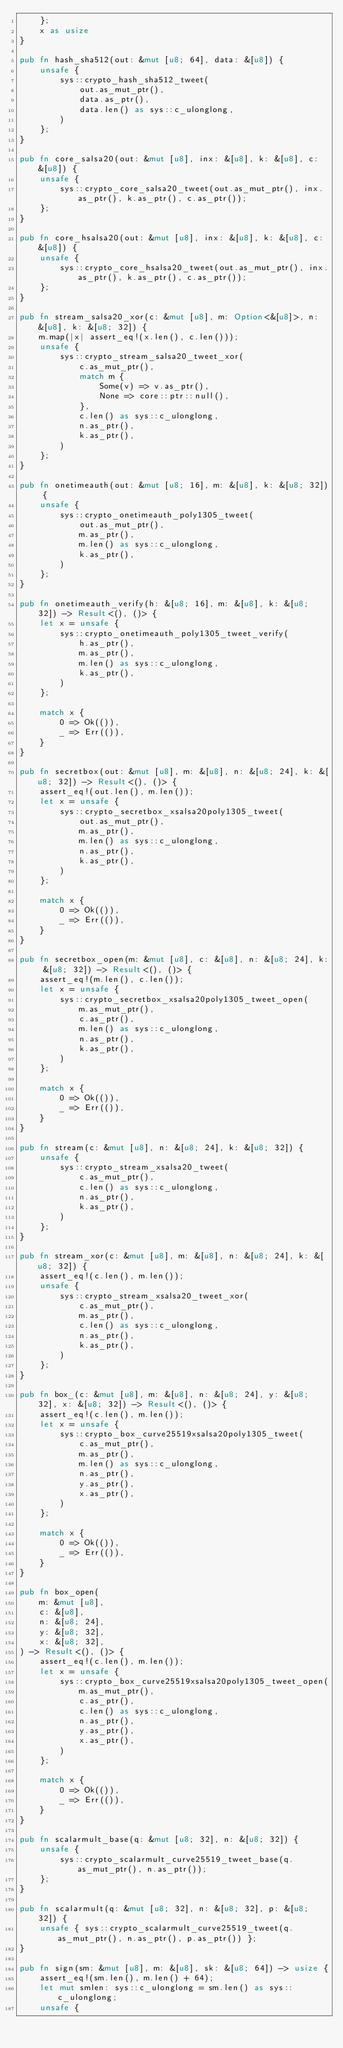Convert code to text. <code><loc_0><loc_0><loc_500><loc_500><_Rust_>    };
    x as usize
}

pub fn hash_sha512(out: &mut [u8; 64], data: &[u8]) {
    unsafe {
        sys::crypto_hash_sha512_tweet(
            out.as_mut_ptr(),
            data.as_ptr(),
            data.len() as sys::c_ulonglong,
        )
    };
}

pub fn core_salsa20(out: &mut [u8], inx: &[u8], k: &[u8], c: &[u8]) {
    unsafe {
        sys::crypto_core_salsa20_tweet(out.as_mut_ptr(), inx.as_ptr(), k.as_ptr(), c.as_ptr());
    };
}

pub fn core_hsalsa20(out: &mut [u8], inx: &[u8], k: &[u8], c: &[u8]) {
    unsafe {
        sys::crypto_core_hsalsa20_tweet(out.as_mut_ptr(), inx.as_ptr(), k.as_ptr(), c.as_ptr());
    };
}

pub fn stream_salsa20_xor(c: &mut [u8], m: Option<&[u8]>, n: &[u8], k: &[u8; 32]) {
    m.map(|x| assert_eq!(x.len(), c.len()));
    unsafe {
        sys::crypto_stream_salsa20_tweet_xor(
            c.as_mut_ptr(),
            match m {
                Some(v) => v.as_ptr(),
                None => core::ptr::null(),
            },
            c.len() as sys::c_ulonglong,
            n.as_ptr(),
            k.as_ptr(),
        )
    };
}

pub fn onetimeauth(out: &mut [u8; 16], m: &[u8], k: &[u8; 32]) {
    unsafe {
        sys::crypto_onetimeauth_poly1305_tweet(
            out.as_mut_ptr(),
            m.as_ptr(),
            m.len() as sys::c_ulonglong,
            k.as_ptr(),
        )
    };
}

pub fn onetimeauth_verify(h: &[u8; 16], m: &[u8], k: &[u8; 32]) -> Result<(), ()> {
    let x = unsafe {
        sys::crypto_onetimeauth_poly1305_tweet_verify(
            h.as_ptr(),
            m.as_ptr(),
            m.len() as sys::c_ulonglong,
            k.as_ptr(),
        )
    };

    match x {
        0 => Ok(()),
        _ => Err(()),
    }
}

pub fn secretbox(out: &mut [u8], m: &[u8], n: &[u8; 24], k: &[u8; 32]) -> Result<(), ()> {
    assert_eq!(out.len(), m.len());
    let x = unsafe {
        sys::crypto_secretbox_xsalsa20poly1305_tweet(
            out.as_mut_ptr(),
            m.as_ptr(),
            m.len() as sys::c_ulonglong,
            n.as_ptr(),
            k.as_ptr(),
        )
    };

    match x {
        0 => Ok(()),
        _ => Err(()),
    }
}

pub fn secretbox_open(m: &mut [u8], c: &[u8], n: &[u8; 24], k: &[u8; 32]) -> Result<(), ()> {
    assert_eq!(m.len(), c.len());
    let x = unsafe {
        sys::crypto_secretbox_xsalsa20poly1305_tweet_open(
            m.as_mut_ptr(),
            c.as_ptr(),
            m.len() as sys::c_ulonglong,
            n.as_ptr(),
            k.as_ptr(),
        )
    };

    match x {
        0 => Ok(()),
        _ => Err(()),
    }
}

pub fn stream(c: &mut [u8], n: &[u8; 24], k: &[u8; 32]) {
    unsafe {
        sys::crypto_stream_xsalsa20_tweet(
            c.as_mut_ptr(),
            c.len() as sys::c_ulonglong,
            n.as_ptr(),
            k.as_ptr(),
        )
    };
}

pub fn stream_xor(c: &mut [u8], m: &[u8], n: &[u8; 24], k: &[u8; 32]) {
    assert_eq!(c.len(), m.len());
    unsafe {
        sys::crypto_stream_xsalsa20_tweet_xor(
            c.as_mut_ptr(),
            m.as_ptr(),
            c.len() as sys::c_ulonglong,
            n.as_ptr(),
            k.as_ptr(),
        )
    };
}

pub fn box_(c: &mut [u8], m: &[u8], n: &[u8; 24], y: &[u8; 32], x: &[u8; 32]) -> Result<(), ()> {
    assert_eq!(c.len(), m.len());
    let x = unsafe {
        sys::crypto_box_curve25519xsalsa20poly1305_tweet(
            c.as_mut_ptr(),
            m.as_ptr(),
            m.len() as sys::c_ulonglong,
            n.as_ptr(),
            y.as_ptr(),
            x.as_ptr(),
        )
    };

    match x {
        0 => Ok(()),
        _ => Err(()),
    }
}

pub fn box_open(
    m: &mut [u8],
    c: &[u8],
    n: &[u8; 24],
    y: &[u8; 32],
    x: &[u8; 32],
) -> Result<(), ()> {
    assert_eq!(c.len(), m.len());
    let x = unsafe {
        sys::crypto_box_curve25519xsalsa20poly1305_tweet_open(
            m.as_mut_ptr(),
            c.as_ptr(),
            c.len() as sys::c_ulonglong,
            n.as_ptr(),
            y.as_ptr(),
            x.as_ptr(),
        )
    };

    match x {
        0 => Ok(()),
        _ => Err(()),
    }
}

pub fn scalarmult_base(q: &mut [u8; 32], n: &[u8; 32]) {
    unsafe {
        sys::crypto_scalarmult_curve25519_tweet_base(q.as_mut_ptr(), n.as_ptr());
    };
}

pub fn scalarmult(q: &mut [u8; 32], n: &[u8; 32], p: &[u8; 32]) {
    unsafe { sys::crypto_scalarmult_curve25519_tweet(q.as_mut_ptr(), n.as_ptr(), p.as_ptr()) };
}

pub fn sign(sm: &mut [u8], m: &[u8], sk: &[u8; 64]) -> usize {
    assert_eq!(sm.len(), m.len() + 64);
    let mut smlen: sys::c_ulonglong = sm.len() as sys::c_ulonglong;
    unsafe {</code> 